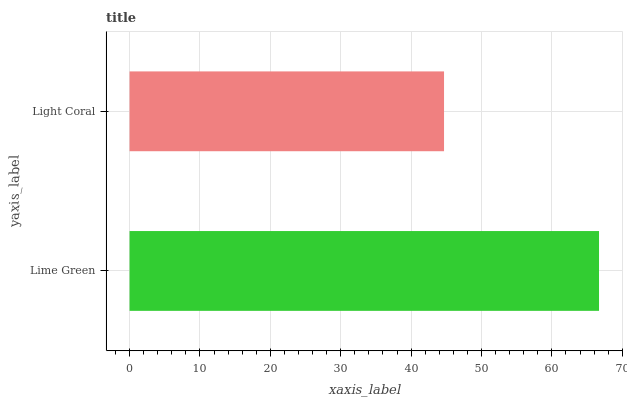Is Light Coral the minimum?
Answer yes or no. Yes. Is Lime Green the maximum?
Answer yes or no. Yes. Is Light Coral the maximum?
Answer yes or no. No. Is Lime Green greater than Light Coral?
Answer yes or no. Yes. Is Light Coral less than Lime Green?
Answer yes or no. Yes. Is Light Coral greater than Lime Green?
Answer yes or no. No. Is Lime Green less than Light Coral?
Answer yes or no. No. Is Lime Green the high median?
Answer yes or no. Yes. Is Light Coral the low median?
Answer yes or no. Yes. Is Light Coral the high median?
Answer yes or no. No. Is Lime Green the low median?
Answer yes or no. No. 